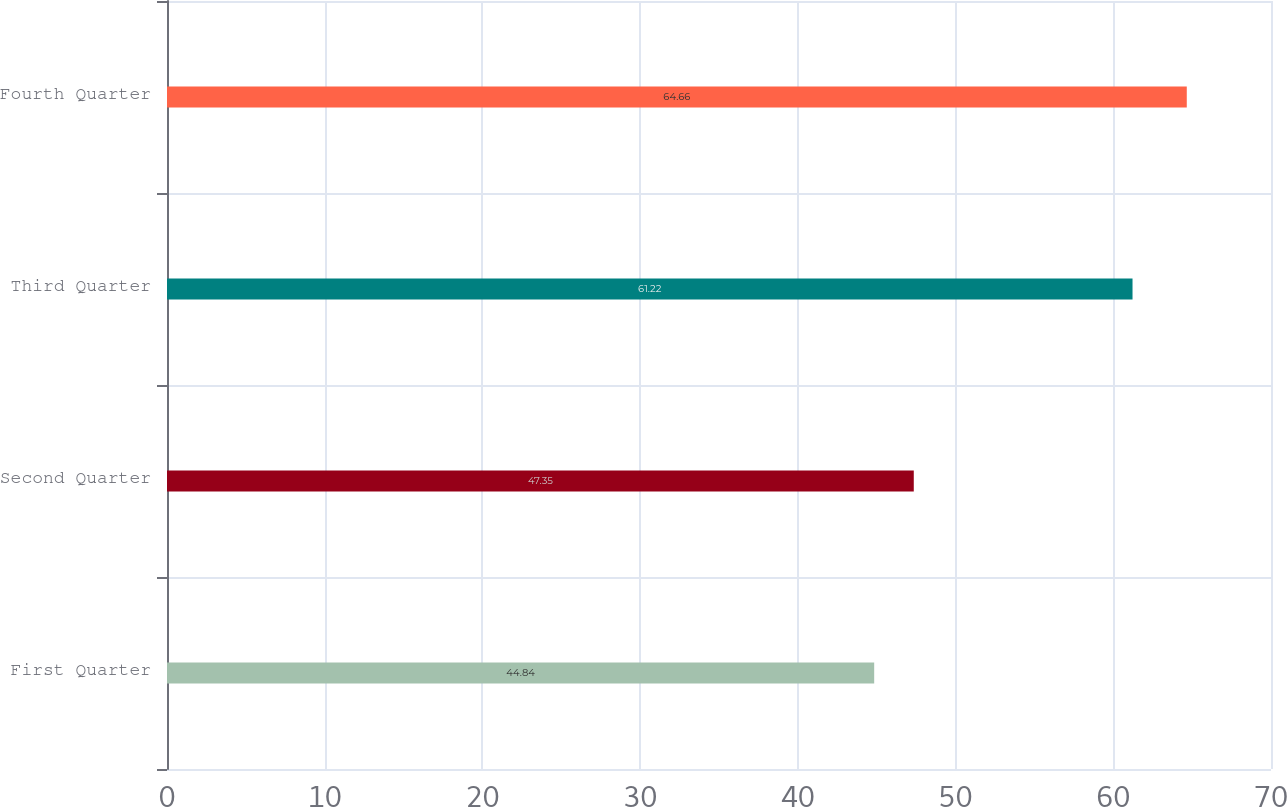Convert chart. <chart><loc_0><loc_0><loc_500><loc_500><bar_chart><fcel>First Quarter<fcel>Second Quarter<fcel>Third Quarter<fcel>Fourth Quarter<nl><fcel>44.84<fcel>47.35<fcel>61.22<fcel>64.66<nl></chart> 